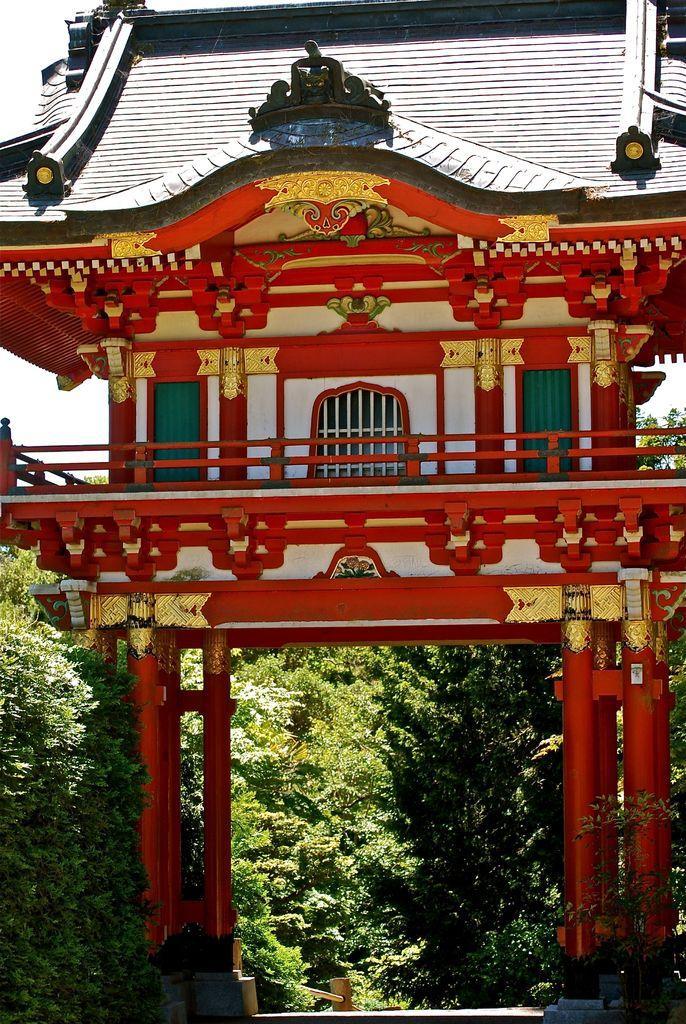How would you summarize this image in a sentence or two? In this picture we can see a temple, pillars, trees. In the background we can see the sky. 